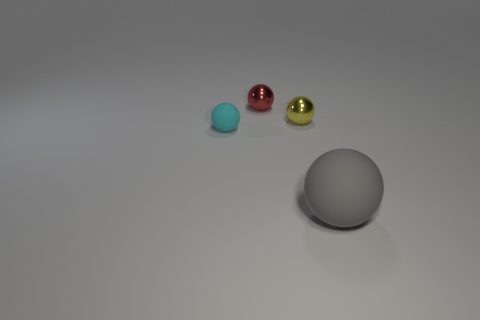Is there another cyan rubber object that has the same size as the cyan object?
Keep it short and to the point. No. What is the material of the yellow object that is the same size as the cyan object?
Keep it short and to the point. Metal. Are there any tiny cyan objects of the same shape as the gray thing?
Ensure brevity in your answer.  Yes. What number of tiny purple rubber blocks are there?
Your answer should be compact. 0. There is a tiny thing that is the same material as the tiny yellow sphere; what is its color?
Provide a succinct answer. Red. How many large things are rubber spheres or gray spheres?
Offer a terse response. 1. There is a gray object; what number of cyan things are in front of it?
Keep it short and to the point. 0. What color is the other small rubber thing that is the same shape as the gray object?
Make the answer very short. Cyan. How many shiny things are either tiny cyan things or big blue cylinders?
Offer a terse response. 0. Are there any balls that are behind the rubber sphere behind the matte object that is to the right of the small red sphere?
Provide a succinct answer. Yes. 